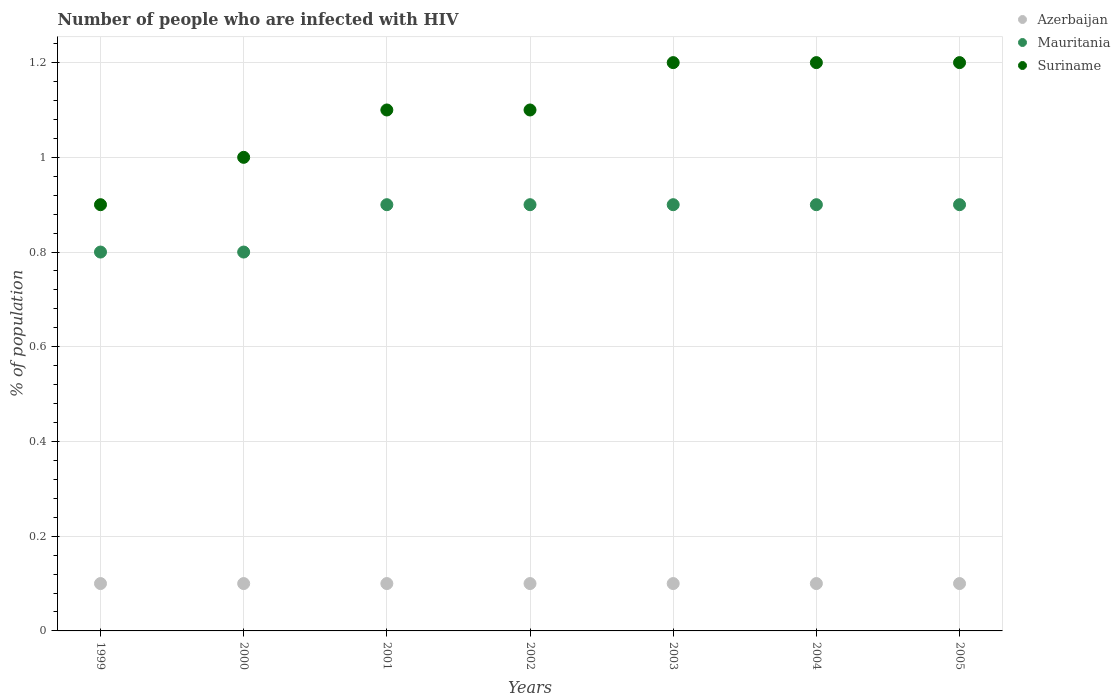How many different coloured dotlines are there?
Make the answer very short. 3. Is the number of dotlines equal to the number of legend labels?
Your answer should be compact. Yes. What is the percentage of HIV infected population in in Mauritania in 1999?
Ensure brevity in your answer.  0.8. Across all years, what is the maximum percentage of HIV infected population in in Suriname?
Give a very brief answer. 1.2. Across all years, what is the minimum percentage of HIV infected population in in Suriname?
Offer a terse response. 0.9. In which year was the percentage of HIV infected population in in Mauritania maximum?
Your response must be concise. 2001. What is the total percentage of HIV infected population in in Suriname in the graph?
Provide a succinct answer. 7.7. What is the difference between the percentage of HIV infected population in in Suriname in 2000 and that in 2004?
Your answer should be very brief. -0.2. In the year 2005, what is the difference between the percentage of HIV infected population in in Mauritania and percentage of HIV infected population in in Suriname?
Provide a short and direct response. -0.3. What is the ratio of the percentage of HIV infected population in in Mauritania in 2000 to that in 2002?
Provide a succinct answer. 0.89. Is the difference between the percentage of HIV infected population in in Mauritania in 2000 and 2004 greater than the difference between the percentage of HIV infected population in in Suriname in 2000 and 2004?
Give a very brief answer. Yes. What is the difference between the highest and the lowest percentage of HIV infected population in in Azerbaijan?
Your response must be concise. 0. In how many years, is the percentage of HIV infected population in in Mauritania greater than the average percentage of HIV infected population in in Mauritania taken over all years?
Ensure brevity in your answer.  5. Does the percentage of HIV infected population in in Azerbaijan monotonically increase over the years?
Provide a short and direct response. No. Is the percentage of HIV infected population in in Mauritania strictly less than the percentage of HIV infected population in in Azerbaijan over the years?
Ensure brevity in your answer.  No. How many dotlines are there?
Give a very brief answer. 3. What is the difference between two consecutive major ticks on the Y-axis?
Your response must be concise. 0.2. Are the values on the major ticks of Y-axis written in scientific E-notation?
Keep it short and to the point. No. How are the legend labels stacked?
Your answer should be compact. Vertical. What is the title of the graph?
Keep it short and to the point. Number of people who are infected with HIV. What is the label or title of the X-axis?
Offer a terse response. Years. What is the label or title of the Y-axis?
Your answer should be very brief. % of population. What is the % of population in Mauritania in 1999?
Offer a terse response. 0.8. What is the % of population of Suriname in 2000?
Ensure brevity in your answer.  1. What is the % of population in Azerbaijan in 2001?
Offer a terse response. 0.1. What is the % of population in Azerbaijan in 2002?
Provide a succinct answer. 0.1. What is the % of population in Mauritania in 2003?
Keep it short and to the point. 0.9. What is the % of population of Azerbaijan in 2004?
Ensure brevity in your answer.  0.1. What is the % of population of Mauritania in 2004?
Your answer should be very brief. 0.9. What is the % of population in Azerbaijan in 2005?
Give a very brief answer. 0.1. What is the % of population of Mauritania in 2005?
Keep it short and to the point. 0.9. What is the % of population of Suriname in 2005?
Your response must be concise. 1.2. Across all years, what is the minimum % of population of Azerbaijan?
Offer a very short reply. 0.1. Across all years, what is the minimum % of population in Mauritania?
Your response must be concise. 0.8. Across all years, what is the minimum % of population of Suriname?
Offer a very short reply. 0.9. What is the total % of population in Mauritania in the graph?
Your answer should be very brief. 6.1. What is the total % of population of Suriname in the graph?
Your answer should be compact. 7.7. What is the difference between the % of population in Azerbaijan in 1999 and that in 2000?
Give a very brief answer. 0. What is the difference between the % of population of Suriname in 1999 and that in 2000?
Ensure brevity in your answer.  -0.1. What is the difference between the % of population of Azerbaijan in 1999 and that in 2002?
Offer a very short reply. 0. What is the difference between the % of population in Azerbaijan in 1999 and that in 2003?
Provide a succinct answer. 0. What is the difference between the % of population of Mauritania in 1999 and that in 2004?
Your answer should be compact. -0.1. What is the difference between the % of population in Mauritania in 1999 and that in 2005?
Make the answer very short. -0.1. What is the difference between the % of population in Azerbaijan in 2000 and that in 2001?
Keep it short and to the point. 0. What is the difference between the % of population in Suriname in 2000 and that in 2001?
Provide a short and direct response. -0.1. What is the difference between the % of population in Mauritania in 2000 and that in 2002?
Provide a short and direct response. -0.1. What is the difference between the % of population in Mauritania in 2000 and that in 2003?
Make the answer very short. -0.1. What is the difference between the % of population in Suriname in 2000 and that in 2003?
Your answer should be compact. -0.2. What is the difference between the % of population of Azerbaijan in 2000 and that in 2004?
Keep it short and to the point. 0. What is the difference between the % of population in Azerbaijan in 2001 and that in 2002?
Your answer should be compact. 0. What is the difference between the % of population in Mauritania in 2001 and that in 2002?
Make the answer very short. 0. What is the difference between the % of population in Suriname in 2001 and that in 2002?
Offer a terse response. 0. What is the difference between the % of population in Azerbaijan in 2001 and that in 2003?
Offer a terse response. 0. What is the difference between the % of population in Suriname in 2001 and that in 2003?
Provide a succinct answer. -0.1. What is the difference between the % of population in Azerbaijan in 2001 and that in 2004?
Ensure brevity in your answer.  0. What is the difference between the % of population of Mauritania in 2001 and that in 2004?
Your answer should be compact. 0. What is the difference between the % of population in Azerbaijan in 2001 and that in 2005?
Keep it short and to the point. 0. What is the difference between the % of population in Mauritania in 2001 and that in 2005?
Provide a succinct answer. 0. What is the difference between the % of population of Suriname in 2002 and that in 2003?
Keep it short and to the point. -0.1. What is the difference between the % of population in Azerbaijan in 2002 and that in 2004?
Provide a short and direct response. 0. What is the difference between the % of population in Suriname in 2002 and that in 2004?
Your answer should be compact. -0.1. What is the difference between the % of population of Suriname in 2003 and that in 2004?
Give a very brief answer. 0. What is the difference between the % of population in Azerbaijan in 2003 and that in 2005?
Offer a very short reply. 0. What is the difference between the % of population in Azerbaijan in 2004 and that in 2005?
Your answer should be compact. 0. What is the difference between the % of population in Azerbaijan in 1999 and the % of population in Mauritania in 2000?
Your answer should be compact. -0.7. What is the difference between the % of population in Azerbaijan in 1999 and the % of population in Suriname in 2000?
Ensure brevity in your answer.  -0.9. What is the difference between the % of population in Mauritania in 1999 and the % of population in Suriname in 2001?
Make the answer very short. -0.3. What is the difference between the % of population in Azerbaijan in 1999 and the % of population in Suriname in 2003?
Provide a short and direct response. -1.1. What is the difference between the % of population in Mauritania in 1999 and the % of population in Suriname in 2003?
Provide a short and direct response. -0.4. What is the difference between the % of population in Azerbaijan in 1999 and the % of population in Suriname in 2005?
Provide a short and direct response. -1.1. What is the difference between the % of population of Azerbaijan in 2000 and the % of population of Suriname in 2001?
Provide a short and direct response. -1. What is the difference between the % of population in Azerbaijan in 2000 and the % of population in Suriname in 2002?
Keep it short and to the point. -1. What is the difference between the % of population of Mauritania in 2000 and the % of population of Suriname in 2002?
Ensure brevity in your answer.  -0.3. What is the difference between the % of population in Mauritania in 2000 and the % of population in Suriname in 2003?
Provide a succinct answer. -0.4. What is the difference between the % of population of Azerbaijan in 2000 and the % of population of Mauritania in 2004?
Give a very brief answer. -0.8. What is the difference between the % of population in Azerbaijan in 2000 and the % of population in Suriname in 2004?
Keep it short and to the point. -1.1. What is the difference between the % of population of Azerbaijan in 2000 and the % of population of Suriname in 2005?
Ensure brevity in your answer.  -1.1. What is the difference between the % of population in Azerbaijan in 2001 and the % of population in Mauritania in 2002?
Make the answer very short. -0.8. What is the difference between the % of population of Azerbaijan in 2001 and the % of population of Suriname in 2002?
Your response must be concise. -1. What is the difference between the % of population of Mauritania in 2001 and the % of population of Suriname in 2002?
Give a very brief answer. -0.2. What is the difference between the % of population in Azerbaijan in 2001 and the % of population in Suriname in 2003?
Ensure brevity in your answer.  -1.1. What is the difference between the % of population of Azerbaijan in 2001 and the % of population of Mauritania in 2005?
Offer a very short reply. -0.8. What is the difference between the % of population of Azerbaijan in 2001 and the % of population of Suriname in 2005?
Offer a very short reply. -1.1. What is the difference between the % of population of Mauritania in 2001 and the % of population of Suriname in 2005?
Offer a very short reply. -0.3. What is the difference between the % of population in Azerbaijan in 2002 and the % of population in Mauritania in 2004?
Make the answer very short. -0.8. What is the difference between the % of population of Azerbaijan in 2002 and the % of population of Suriname in 2004?
Ensure brevity in your answer.  -1.1. What is the difference between the % of population in Azerbaijan in 2002 and the % of population in Suriname in 2005?
Your answer should be compact. -1.1. What is the difference between the % of population of Mauritania in 2002 and the % of population of Suriname in 2005?
Your answer should be compact. -0.3. What is the difference between the % of population of Azerbaijan in 2003 and the % of population of Suriname in 2004?
Offer a terse response. -1.1. What is the difference between the % of population in Mauritania in 2003 and the % of population in Suriname in 2004?
Ensure brevity in your answer.  -0.3. What is the difference between the % of population in Azerbaijan in 2003 and the % of population in Suriname in 2005?
Provide a succinct answer. -1.1. What is the difference between the % of population in Azerbaijan in 2004 and the % of population in Suriname in 2005?
Provide a short and direct response. -1.1. What is the average % of population of Mauritania per year?
Provide a short and direct response. 0.87. What is the average % of population of Suriname per year?
Provide a succinct answer. 1.1. In the year 1999, what is the difference between the % of population in Azerbaijan and % of population in Mauritania?
Offer a terse response. -0.7. In the year 1999, what is the difference between the % of population of Azerbaijan and % of population of Suriname?
Keep it short and to the point. -0.8. In the year 2000, what is the difference between the % of population of Azerbaijan and % of population of Suriname?
Give a very brief answer. -0.9. In the year 2000, what is the difference between the % of population in Mauritania and % of population in Suriname?
Offer a very short reply. -0.2. In the year 2001, what is the difference between the % of population of Azerbaijan and % of population of Mauritania?
Keep it short and to the point. -0.8. In the year 2002, what is the difference between the % of population of Azerbaijan and % of population of Mauritania?
Offer a terse response. -0.8. In the year 2002, what is the difference between the % of population in Azerbaijan and % of population in Suriname?
Offer a terse response. -1. In the year 2002, what is the difference between the % of population in Mauritania and % of population in Suriname?
Offer a terse response. -0.2. In the year 2003, what is the difference between the % of population of Azerbaijan and % of population of Suriname?
Your response must be concise. -1.1. In the year 2003, what is the difference between the % of population of Mauritania and % of population of Suriname?
Make the answer very short. -0.3. In the year 2004, what is the difference between the % of population of Azerbaijan and % of population of Mauritania?
Offer a very short reply. -0.8. In the year 2004, what is the difference between the % of population of Azerbaijan and % of population of Suriname?
Your answer should be compact. -1.1. In the year 2005, what is the difference between the % of population in Azerbaijan and % of population in Mauritania?
Keep it short and to the point. -0.8. In the year 2005, what is the difference between the % of population of Azerbaijan and % of population of Suriname?
Ensure brevity in your answer.  -1.1. In the year 2005, what is the difference between the % of population in Mauritania and % of population in Suriname?
Make the answer very short. -0.3. What is the ratio of the % of population of Azerbaijan in 1999 to that in 2000?
Offer a terse response. 1. What is the ratio of the % of population of Mauritania in 1999 to that in 2000?
Keep it short and to the point. 1. What is the ratio of the % of population in Suriname in 1999 to that in 2000?
Give a very brief answer. 0.9. What is the ratio of the % of population in Azerbaijan in 1999 to that in 2001?
Your answer should be compact. 1. What is the ratio of the % of population of Suriname in 1999 to that in 2001?
Your answer should be very brief. 0.82. What is the ratio of the % of population in Suriname in 1999 to that in 2002?
Your answer should be very brief. 0.82. What is the ratio of the % of population in Mauritania in 1999 to that in 2003?
Give a very brief answer. 0.89. What is the ratio of the % of population in Suriname in 1999 to that in 2004?
Your response must be concise. 0.75. What is the ratio of the % of population in Mauritania in 1999 to that in 2005?
Keep it short and to the point. 0.89. What is the ratio of the % of population of Mauritania in 2000 to that in 2001?
Make the answer very short. 0.89. What is the ratio of the % of population in Suriname in 2000 to that in 2002?
Offer a very short reply. 0.91. What is the ratio of the % of population in Azerbaijan in 2000 to that in 2003?
Offer a very short reply. 1. What is the ratio of the % of population in Suriname in 2000 to that in 2003?
Your answer should be compact. 0.83. What is the ratio of the % of population of Mauritania in 2000 to that in 2005?
Offer a terse response. 0.89. What is the ratio of the % of population in Suriname in 2000 to that in 2005?
Offer a terse response. 0.83. What is the ratio of the % of population of Azerbaijan in 2001 to that in 2002?
Your answer should be compact. 1. What is the ratio of the % of population of Mauritania in 2001 to that in 2002?
Your answer should be compact. 1. What is the ratio of the % of population of Suriname in 2001 to that in 2002?
Provide a succinct answer. 1. What is the ratio of the % of population in Azerbaijan in 2001 to that in 2003?
Ensure brevity in your answer.  1. What is the ratio of the % of population of Suriname in 2001 to that in 2003?
Provide a short and direct response. 0.92. What is the ratio of the % of population of Azerbaijan in 2001 to that in 2004?
Your answer should be compact. 1. What is the ratio of the % of population in Mauritania in 2001 to that in 2004?
Your response must be concise. 1. What is the ratio of the % of population in Mauritania in 2001 to that in 2005?
Ensure brevity in your answer.  1. What is the ratio of the % of population of Mauritania in 2002 to that in 2003?
Your answer should be compact. 1. What is the ratio of the % of population in Azerbaijan in 2002 to that in 2004?
Your response must be concise. 1. What is the ratio of the % of population in Mauritania in 2002 to that in 2004?
Provide a short and direct response. 1. What is the ratio of the % of population in Azerbaijan in 2002 to that in 2005?
Your answer should be very brief. 1. What is the ratio of the % of population of Mauritania in 2002 to that in 2005?
Your response must be concise. 1. What is the ratio of the % of population of Mauritania in 2003 to that in 2004?
Give a very brief answer. 1. What is the ratio of the % of population in Suriname in 2003 to that in 2004?
Give a very brief answer. 1. What is the ratio of the % of population of Mauritania in 2003 to that in 2005?
Provide a succinct answer. 1. What is the ratio of the % of population of Suriname in 2003 to that in 2005?
Your answer should be very brief. 1. What is the ratio of the % of population of Suriname in 2004 to that in 2005?
Your response must be concise. 1. What is the difference between the highest and the second highest % of population of Azerbaijan?
Provide a succinct answer. 0. What is the difference between the highest and the second highest % of population in Mauritania?
Provide a short and direct response. 0. 